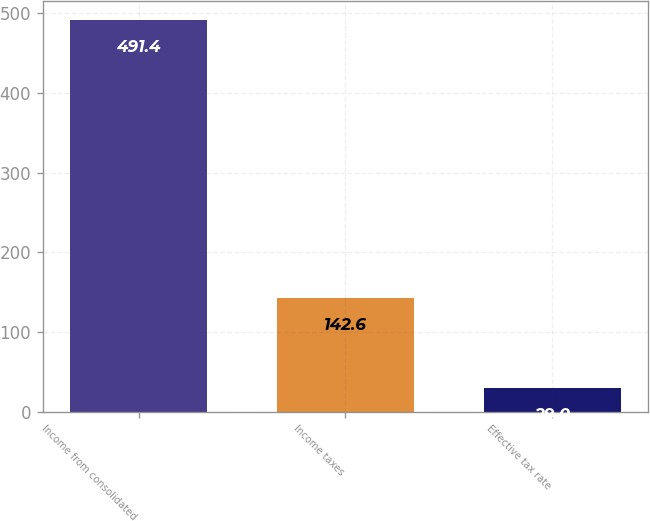Convert chart to OTSL. <chart><loc_0><loc_0><loc_500><loc_500><bar_chart><fcel>Income from consolidated<fcel>Income taxes<fcel>Effective tax rate<nl><fcel>491.4<fcel>142.6<fcel>29<nl></chart> 